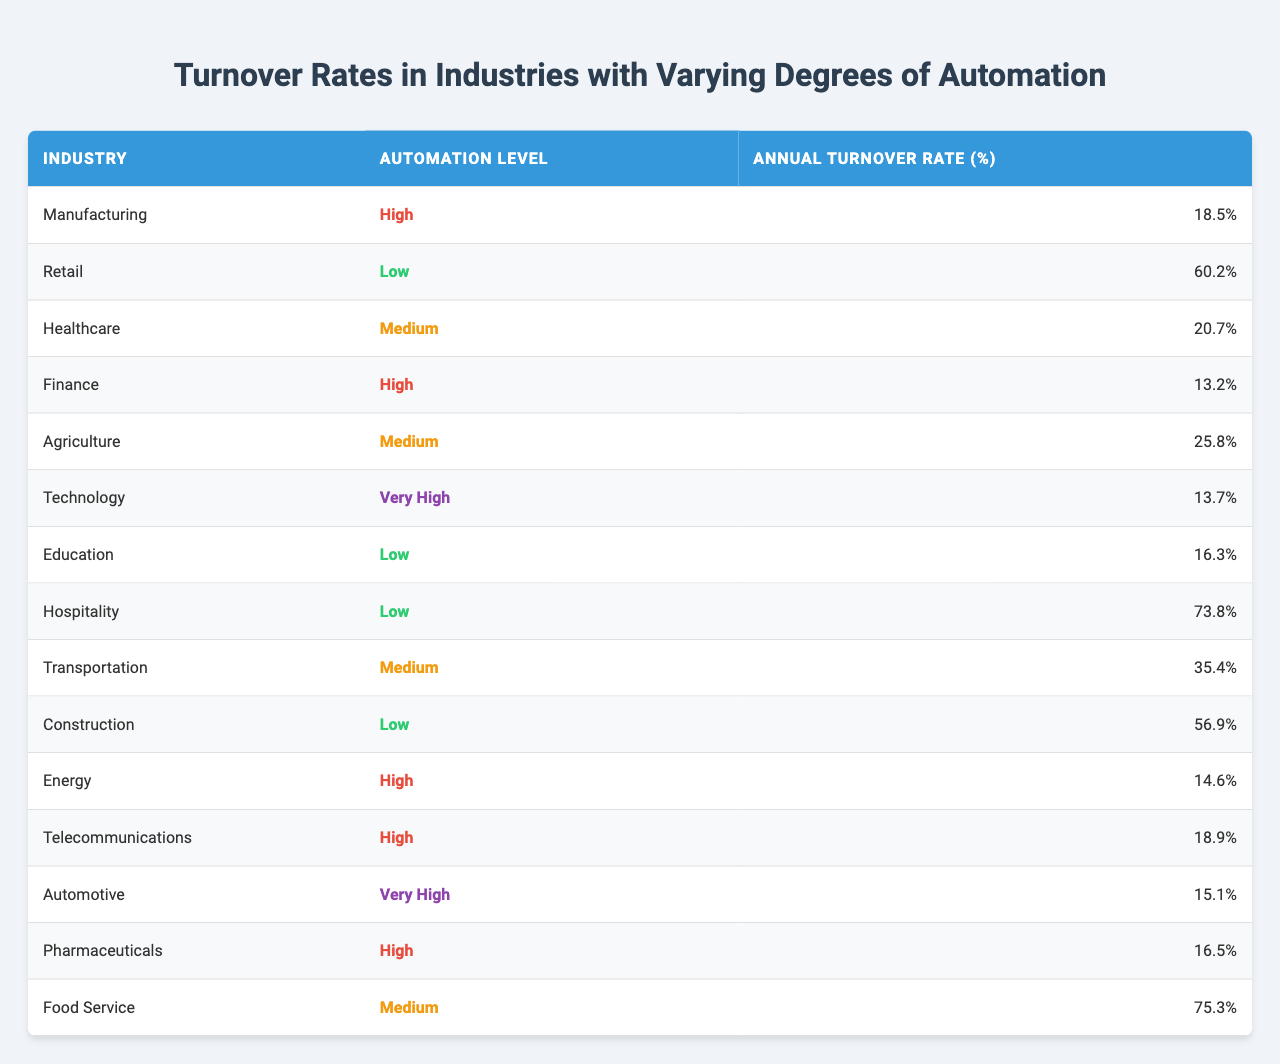What industry has the highest turnover rate? Referring to the table, the industry with the highest turnover rate is "Food Service" with a rate of 75.3%.
Answer: Food Service Which industry has a medium level of automation and the lowest turnover rate? The data shows that "Healthcare" is the only industry labeled as medium automation that has a turnover rate of 20.7%, which is lower than others in the same category.
Answer: Healthcare Is the turnover rate in the Automotive industry higher than in the Pharmaceuticals industry? The Automotive industry has a turnover rate of 15.1%, while the Pharmaceuticals industry has a turnover rate of 16.5%. Thus, Automotive's rate is lower.
Answer: No What is the average turnover rate for industries with high automation? The industries with high automation are Manufacturing (18.5%), Finance (13.2%), Energy (14.6%), Telecommunications (18.9%), and Pharmaceuticals (16.5%). The average is (18.5 + 13.2 + 14.6 + 18.9 + 16.5) / 5 = 16.74%.
Answer: 16.74% Does the Hospitality industry have a higher turnover rate than the Retail industry? The Hospitality industry has a turnover rate of 73.8%, and Retail has a rate of 60.2%. Since 73.8% is greater than 60.2%, the statement is true.
Answer: Yes What is the difference in turnover rates between the highest and lowest turnover industries? The highest turnover rate is in the Food Service industry (75.3%) and the lowest is in the Finance industry (13.2%). The difference is 75.3% - 13.2% = 62.1%.
Answer: 62.1% How many industries have an automation level categorized as low? The industries with a low automation level are Retail, Education, Hospitality, and Construction, totaling four industries.
Answer: 4 What percentage of turnover does the Technology industry represent compared to the average turnover for high automation industries? The Technology industry has a turnover rate of 13.7%. The average turnover for high automation industries is 16.74%. Then, (13.7 / 16.74) * 100 ≈ 81.88%.
Answer: 81.88% Which industry with very high automation has the closest turnover rate to the industry with low automation? The industry with very high automation is Technology (13.7%) and Automotive (15.1%). The industry with low automation closest to them is Hospitality (73.8%). The closest turnover rates are Automotive and Pharmaceuticals.
Answer: Automotive (15.1%) In total, how many industries have a turnover rate greater than 30%? By examining the data, the industries with rates greater than 30% are Retail (60.2%), Hospitality (73.8%), Transportation (35.4%), Agriculture (25.8%), and Food Service (75.3%). Thus, there are five industries above this threshold.
Answer: 5 